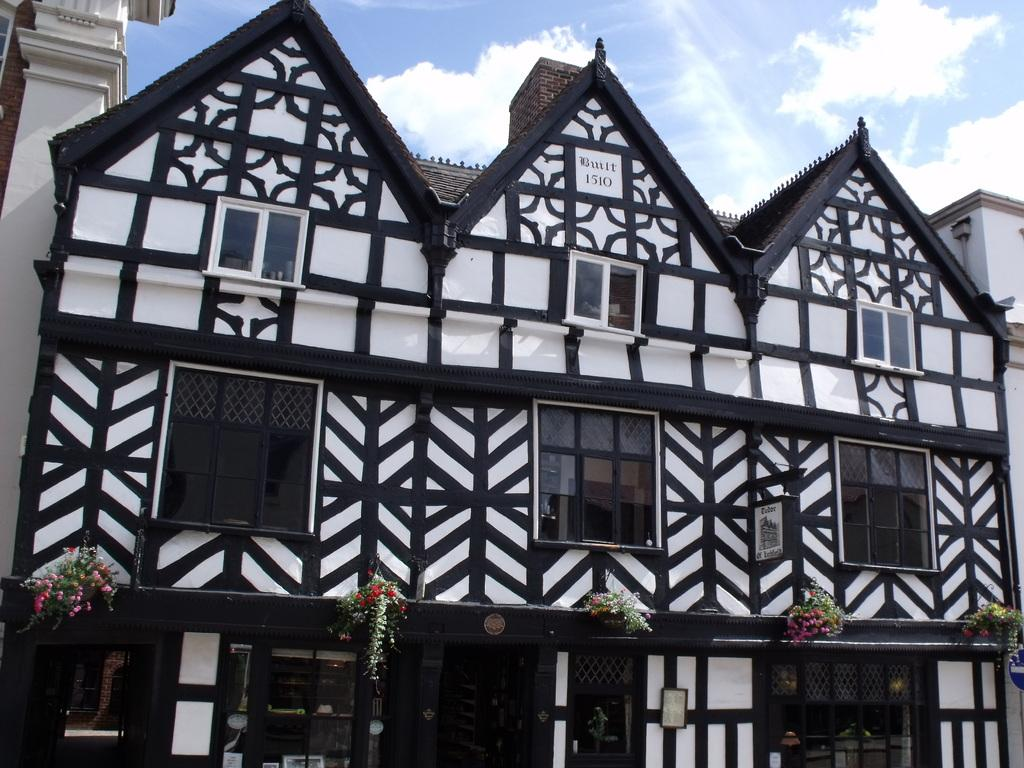What type of structure is in the image? There is a house in the image. What features can be seen on the house? The house has windows and a door at the bottom of the image. What objects are present near the house? There are flower pots in the image. What is visible at the top of the image? The sky is visible at the top of the image, and clouds are present in the sky. What type of apparatus is used to cover the windows in the image? There is no apparatus mentioned or visible in the image for covering the windows; the windows are simply visible on the house. What kind of pipe can be seen connecting the house to the flower pots? There is no pipe connecting the house to the flower pots in the image. 